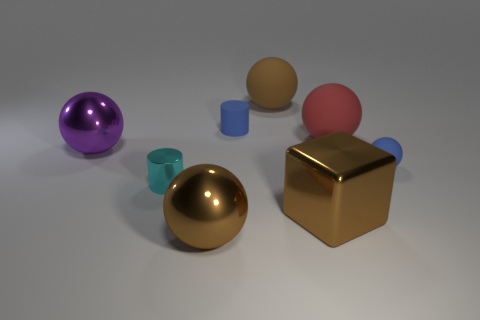Are there more red objects to the left of the tiny blue matte cylinder than small cyan shiny cubes?
Make the answer very short. No. Is the size of the metal sphere behind the cyan metal cylinder the same as the red object?
Your answer should be very brief. Yes. There is a sphere that is both in front of the big red rubber ball and to the right of the large brown block; what is its color?
Offer a terse response. Blue. What shape is the matte object that is the same size as the blue sphere?
Make the answer very short. Cylinder. Are there any small matte spheres that have the same color as the metallic cylinder?
Provide a short and direct response. No. Are there the same number of big brown spheres in front of the large purple metallic thing and big gray shiny balls?
Offer a terse response. No. Do the small matte cylinder and the large block have the same color?
Ensure brevity in your answer.  No. There is a ball that is both to the right of the brown metal ball and to the left of the red rubber thing; what size is it?
Provide a succinct answer. Large. There is a tiny object that is made of the same material as the brown cube; what is its color?
Offer a very short reply. Cyan. What number of tiny cyan cylinders are made of the same material as the brown block?
Provide a succinct answer. 1. 